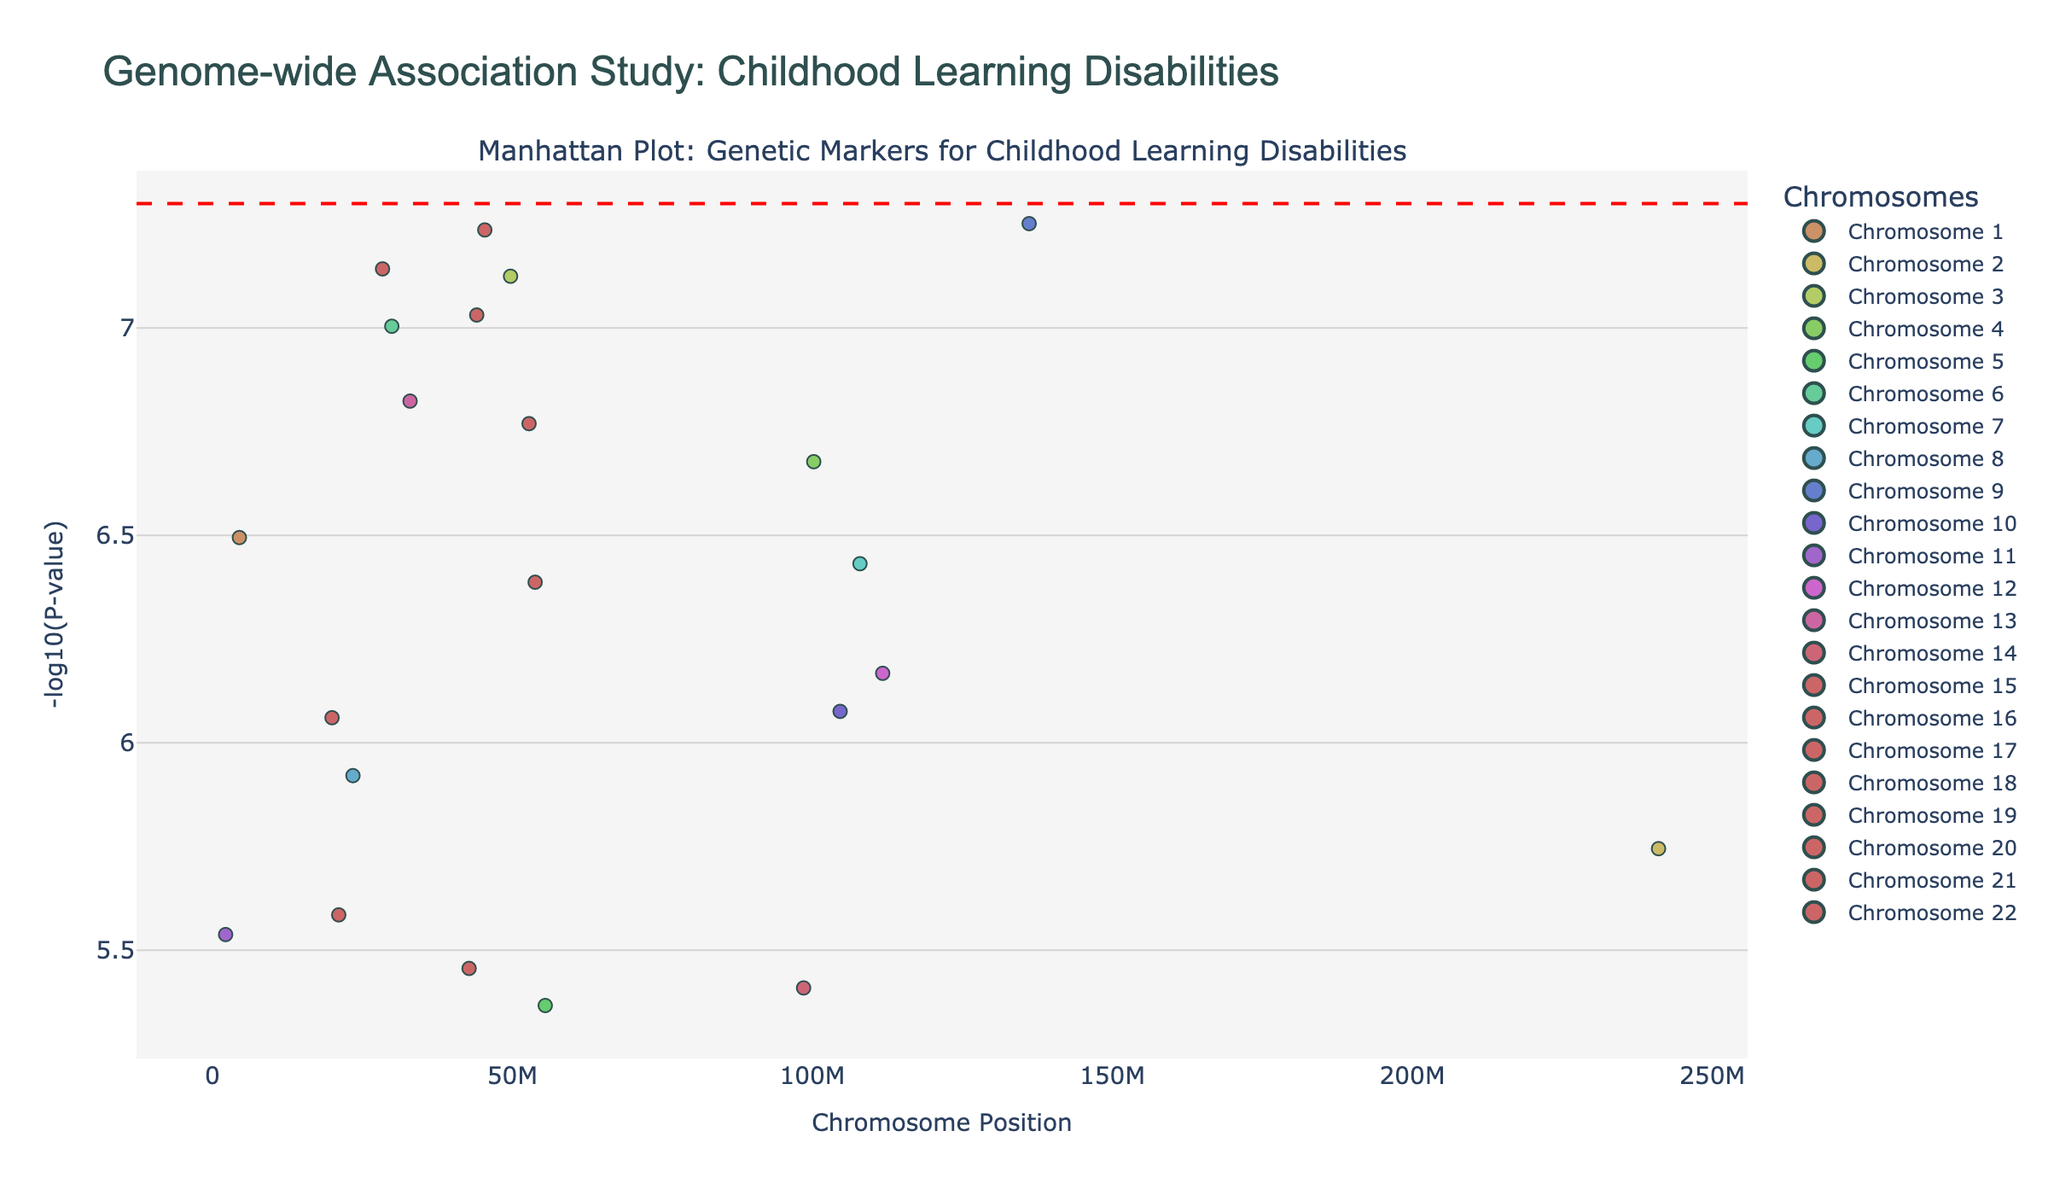What's the title of the plot? The title can be found at the top of the figure, which reads "Genome-wide Association Study: Childhood Learning Disabilities".
Answer: Genome-wide Association Study: Childhood Learning Disabilities What does the y-axis represent? The label on the y-axis reads "-log10(P-value)", which indicates it represents the -log10 transformation of the P-value for each SNP.
Answer: -log10(P-value) How many chromosomes are represented in the plot? The legend shows color-coded information for each chromosome from 1 to 22, so we have 22 chromosomes represented.
Answer: 22 Which SNP has the smallest P-value? The smallest P-value corresponds to the highest -log10(P-value). By examining all data points, the SNP with the highest position on the y-axis is rs9267673.
Answer: rs9267673 Is there a significance threshold line in the plot? Yes, the plot includes a red dashed line, which is commonly drawn at -log10(5e-8), indicating a significance threshold.
Answer: Yes How many SNPs are above the significance threshold line? Counting the data points that fall above the red dashed line, there are 8 SNPs above the significance threshold.
Answer: 8 Which chromosome has the most significant SNPs above the threshold? By checking the colors and carefully counting the data points above the significance threshold, we see that Chromosome 9 has more SNPs above the threshold line compared to others.
Answer: Chromosome 9 Compare the significance of SNPs on Chromosome 1 to those on Chromosome 6. By looking at the height of the data points (i.e., their -log10(P-value)), Chromosome 6 generally has more significant SNPs with higher values compared to Chromosome 1.
Answer: Chromosome 6 has more significant SNPs What does a higher position on the y-axis indicate about a SNP's P-value? A higher position on the y-axis means a higher -log10(P-value), which corresponds to a smaller and more significant P-value.
Answer: Smaller P-value Identify the SNP with the largest -log10(P-value) on Chromosome 17. By locating Chromosome 17's color in the legend and examining the height of the data points, the highest point is associated with rs142920.
Answer: rs142920 